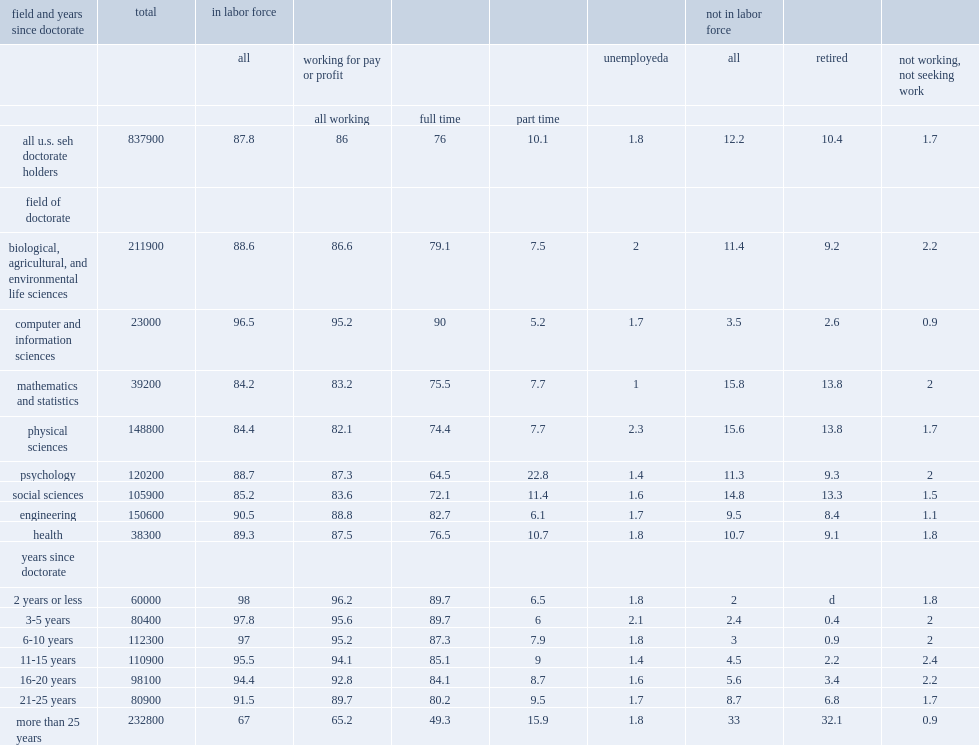Of the total seh doctoral population in february 2013, how many percent was in the labor force? 87.8. Of the total seh doctoral population in february 2013, how many percent of working full time? 76.0. Of the total seh doctoral population in february 2013, how many percent of working part time? 10.1. How many percent of the seh doctoral population was retired in 2013? 10.4. How many percent of the seh doctoral population was not seeking work in 2013? 1.7. Across seh degree fields, how many percent was full-time employment for psychology doctorates? 64.5. Across seh degree fields, how many percent was full-time employment for computer and information sciences doctorates? 90.0. 